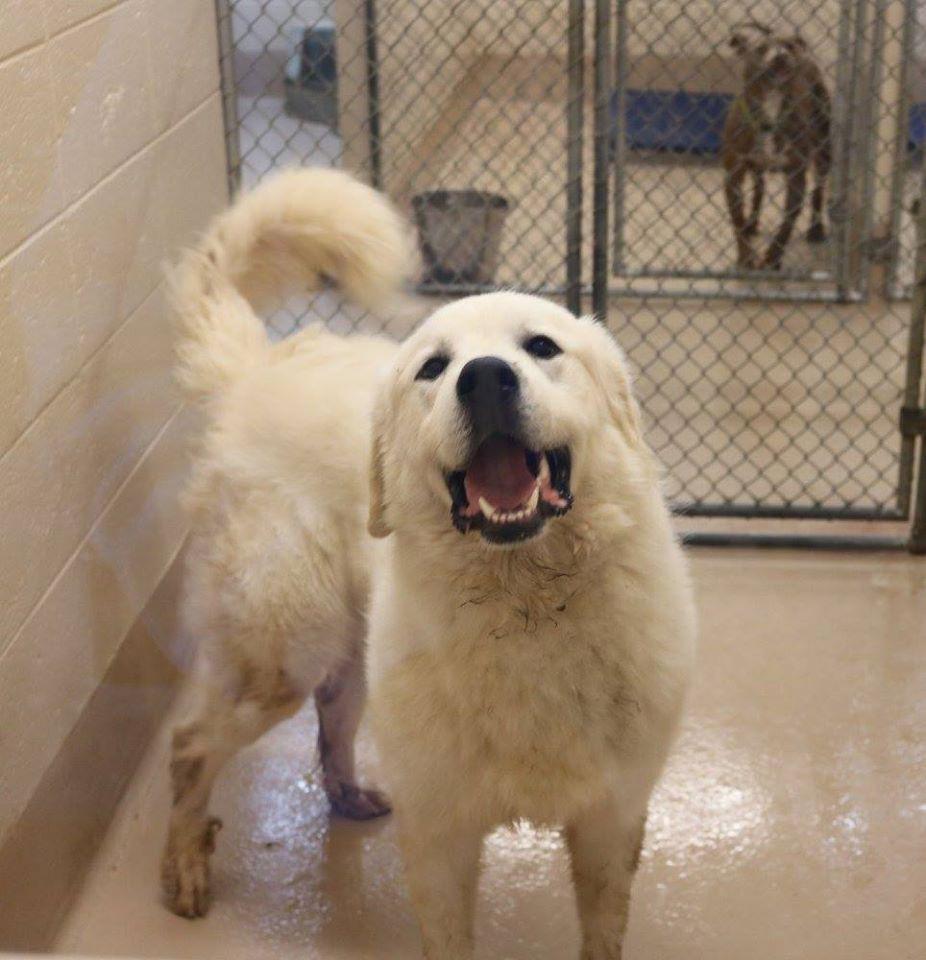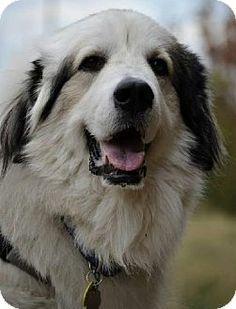The first image is the image on the left, the second image is the image on the right. Assess this claim about the two images: "One dog is sitting.". Correct or not? Answer yes or no. No. 